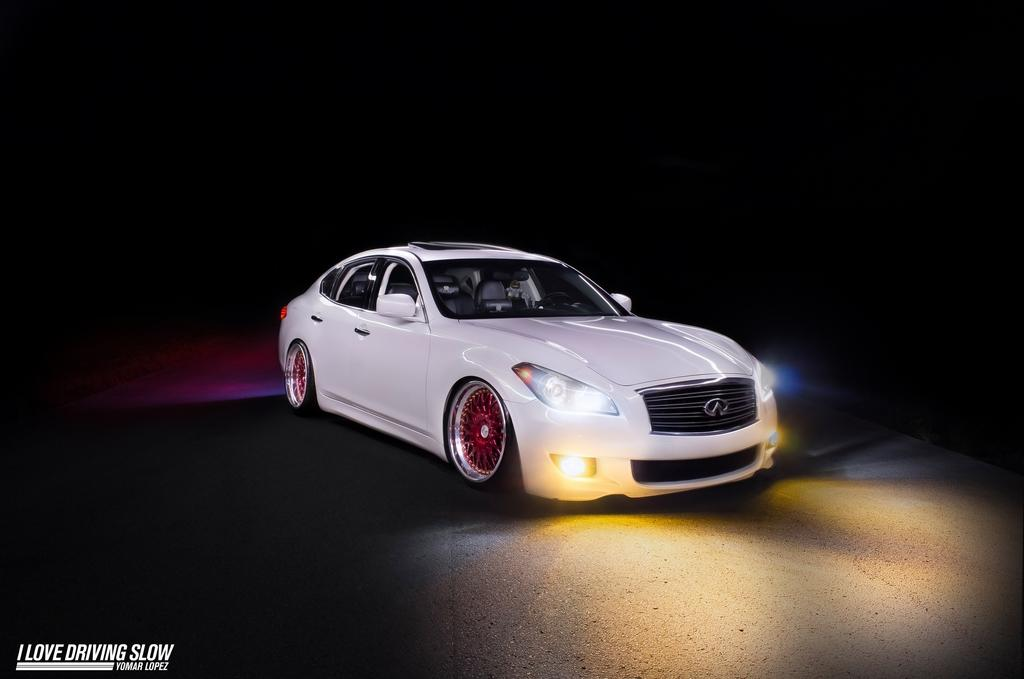What is the color of the car in the picture? The car in the picture is white. Is there any text visible in the picture? Yes, there is text on the bottom left corner of the picture. What color is the background of the picture? The background of the picture is black. What type of pancake is being flipped in the picture? There is no pancake present in the picture; it features a white car with text on a black background. 